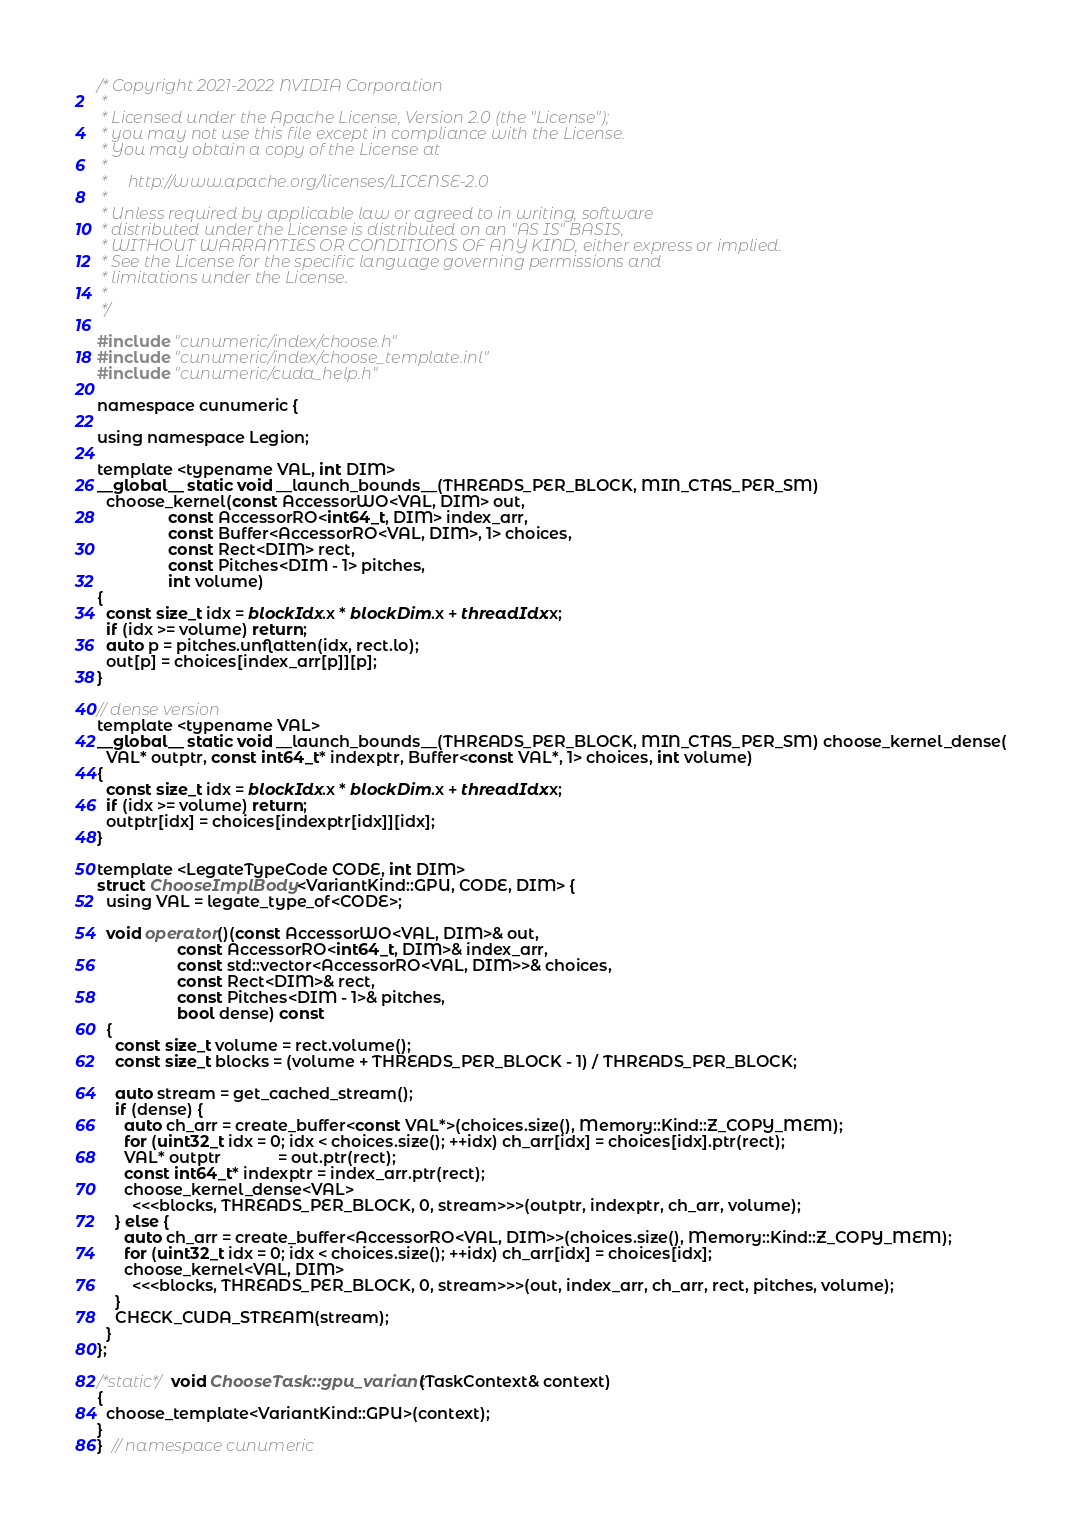<code> <loc_0><loc_0><loc_500><loc_500><_Cuda_>/* Copyright 2021-2022 NVIDIA Corporation
 *
 * Licensed under the Apache License, Version 2.0 (the "License");
 * you may not use this file except in compliance with the License.
 * You may obtain a copy of the License at
 *
 *     http://www.apache.org/licenses/LICENSE-2.0
 *
 * Unless required by applicable law or agreed to in writing, software
 * distributed under the License is distributed on an "AS IS" BASIS,
 * WITHOUT WARRANTIES OR CONDITIONS OF ANY KIND, either express or implied.
 * See the License for the specific language governing permissions and
 * limitations under the License.
 *
 */

#include "cunumeric/index/choose.h"
#include "cunumeric/index/choose_template.inl"
#include "cunumeric/cuda_help.h"

namespace cunumeric {

using namespace Legion;

template <typename VAL, int DIM>
__global__ static void __launch_bounds__(THREADS_PER_BLOCK, MIN_CTAS_PER_SM)
  choose_kernel(const AccessorWO<VAL, DIM> out,
                const AccessorRO<int64_t, DIM> index_arr,
                const Buffer<AccessorRO<VAL, DIM>, 1> choices,
                const Rect<DIM> rect,
                const Pitches<DIM - 1> pitches,
                int volume)
{
  const size_t idx = blockIdx.x * blockDim.x + threadIdx.x;
  if (idx >= volume) return;
  auto p = pitches.unflatten(idx, rect.lo);
  out[p] = choices[index_arr[p]][p];
}

// dense version
template <typename VAL>
__global__ static void __launch_bounds__(THREADS_PER_BLOCK, MIN_CTAS_PER_SM) choose_kernel_dense(
  VAL* outptr, const int64_t* indexptr, Buffer<const VAL*, 1> choices, int volume)
{
  const size_t idx = blockIdx.x * blockDim.x + threadIdx.x;
  if (idx >= volume) return;
  outptr[idx] = choices[indexptr[idx]][idx];
}

template <LegateTypeCode CODE, int DIM>
struct ChooseImplBody<VariantKind::GPU, CODE, DIM> {
  using VAL = legate_type_of<CODE>;

  void operator()(const AccessorWO<VAL, DIM>& out,
                  const AccessorRO<int64_t, DIM>& index_arr,
                  const std::vector<AccessorRO<VAL, DIM>>& choices,
                  const Rect<DIM>& rect,
                  const Pitches<DIM - 1>& pitches,
                  bool dense) const
  {
    const size_t volume = rect.volume();
    const size_t blocks = (volume + THREADS_PER_BLOCK - 1) / THREADS_PER_BLOCK;

    auto stream = get_cached_stream();
    if (dense) {
      auto ch_arr = create_buffer<const VAL*>(choices.size(), Memory::Kind::Z_COPY_MEM);
      for (uint32_t idx = 0; idx < choices.size(); ++idx) ch_arr[idx] = choices[idx].ptr(rect);
      VAL* outptr             = out.ptr(rect);
      const int64_t* indexptr = index_arr.ptr(rect);
      choose_kernel_dense<VAL>
        <<<blocks, THREADS_PER_BLOCK, 0, stream>>>(outptr, indexptr, ch_arr, volume);
    } else {
      auto ch_arr = create_buffer<AccessorRO<VAL, DIM>>(choices.size(), Memory::Kind::Z_COPY_MEM);
      for (uint32_t idx = 0; idx < choices.size(); ++idx) ch_arr[idx] = choices[idx];
      choose_kernel<VAL, DIM>
        <<<blocks, THREADS_PER_BLOCK, 0, stream>>>(out, index_arr, ch_arr, rect, pitches, volume);
    }
    CHECK_CUDA_STREAM(stream);
  }
};

/*static*/ void ChooseTask::gpu_variant(TaskContext& context)
{
  choose_template<VariantKind::GPU>(context);
}
}  // namespace cunumeric
</code> 